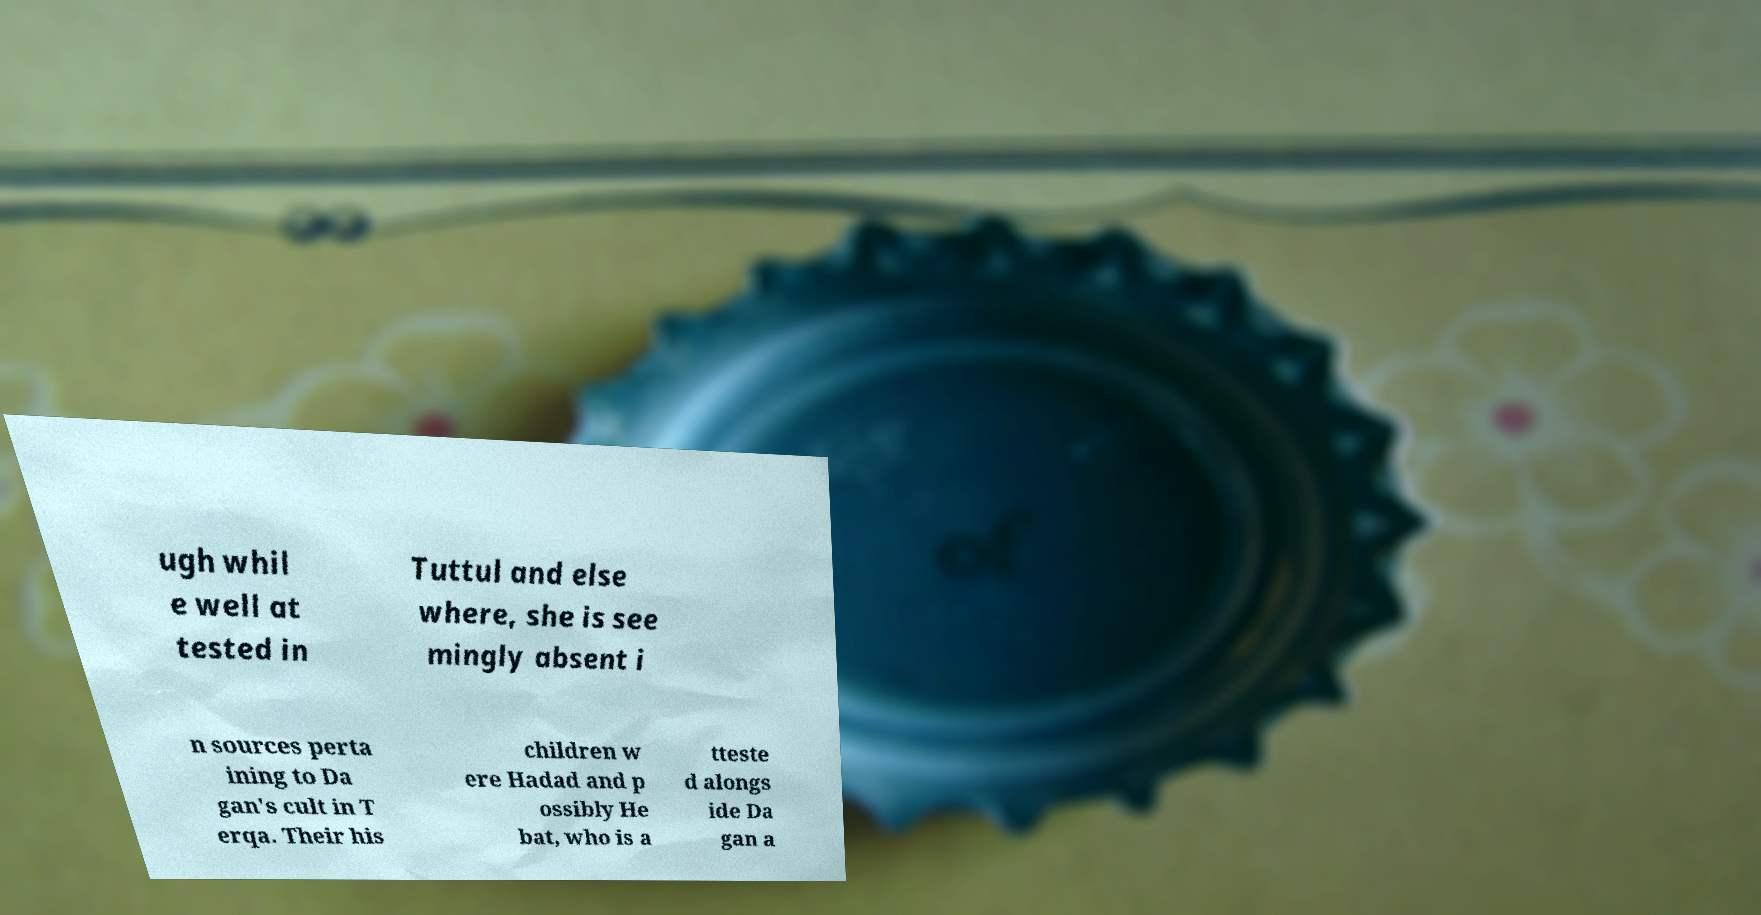For documentation purposes, I need the text within this image transcribed. Could you provide that? ugh whil e well at tested in Tuttul and else where, she is see mingly absent i n sources perta ining to Da gan's cult in T erqa. Their his children w ere Hadad and p ossibly He bat, who is a tteste d alongs ide Da gan a 